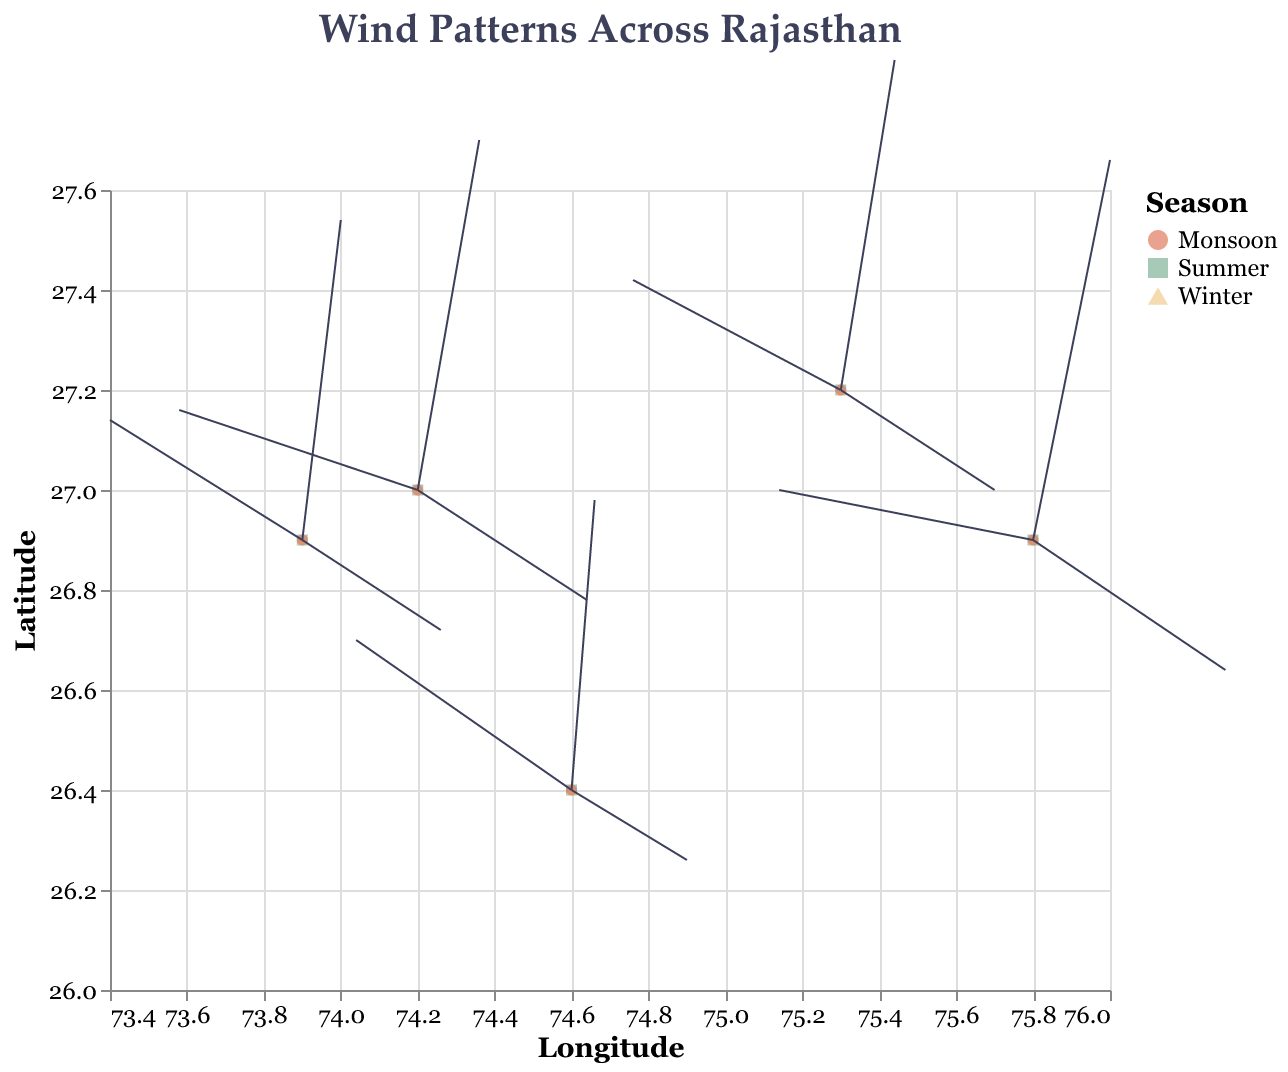What is the title of the figure? The title of the figure can be found at the top of the visual diagram. It reads "Wind Patterns Across Rajasthan."
Answer: Wind Patterns Across Rajasthan Which season is represented by the orange color in the plot? In the legend of the plot, each color represents a different season. Orange color corresponds to the "Summer" season.
Answer: Summer How does wind direction in Jodhpur change from Summer to Winter? In Summer, the wind in Jodhpur has direction components U=-2.5 and V=1.2, which means it moves westward and slightly northward. In Winter, the direction components are U=1.8 and V=-0.9, indicating a shift towards eastward and slightly southward.
Answer: From westward/northward to eastward/southward Which location has the highest wind intensity during the Monsoon season? Wind intensity can be determined by the magnitude of the vector (U, V). We calculate the magnitudes for each location during Monsoon and compare them. The highest magnitude is in Jaipur (sqrt(1.0^2 + 3.8^2) ≈ 3.88).
Answer: Jaipur What is the visual significance of the arrows in the plot? The arrows, drawn from the points with certain direction and length, represent the wind direction (U, V) and intensity for each location in various seasons.
Answer: Represent wind direction and intensity How does the direction of wind in Ajmer differ between Winter and Monsoon? In Winter, Ajmer's wind direction components are U=2.2 and V=-1.1, indicating movement towards the east and slightly south. In Monsoon, the components are U=0.8 and V=3.5, indicating a shift towards the north with a slight eastward direction.
Answer: From eastward/southward to northward/eastward Identify the regions experiencing northward winds during Summer. Northward wind direction has a positive V component. Referring to the data, this occurs in Jodhpur (V=1.2), Udaipur (V=1.5), and Alwar (V=1.1).
Answer: Jodhpur, Udaipur, Alwar Compare wind intensities (magnitude) across locations in Alwar during Summer and Winter. The wind intensity is calculated as the magnitude sqrt(U^2 + V^2). For Alwar in Summer, it's sqrt((-2.7)^2 + 1.1^2) ≈ 2.93. In Winter, it is sqrt((2.0)^2 + (-1.0)^2) ≈ 2.24. The intensity is higher in Summer.
Answer: Higher in Summer What's the average wind U component in Jaipur across all seasons? Sum the U component values for Jaipur across all seasons: -3.3 (Summer) + 2.5 (Winter) + 1.0 (Monsoon). Then, divide by the number of seasons (3): (-3.3 + 2.5 + 1.0)/3 ≈ 0.07.
Answer: 0.07 